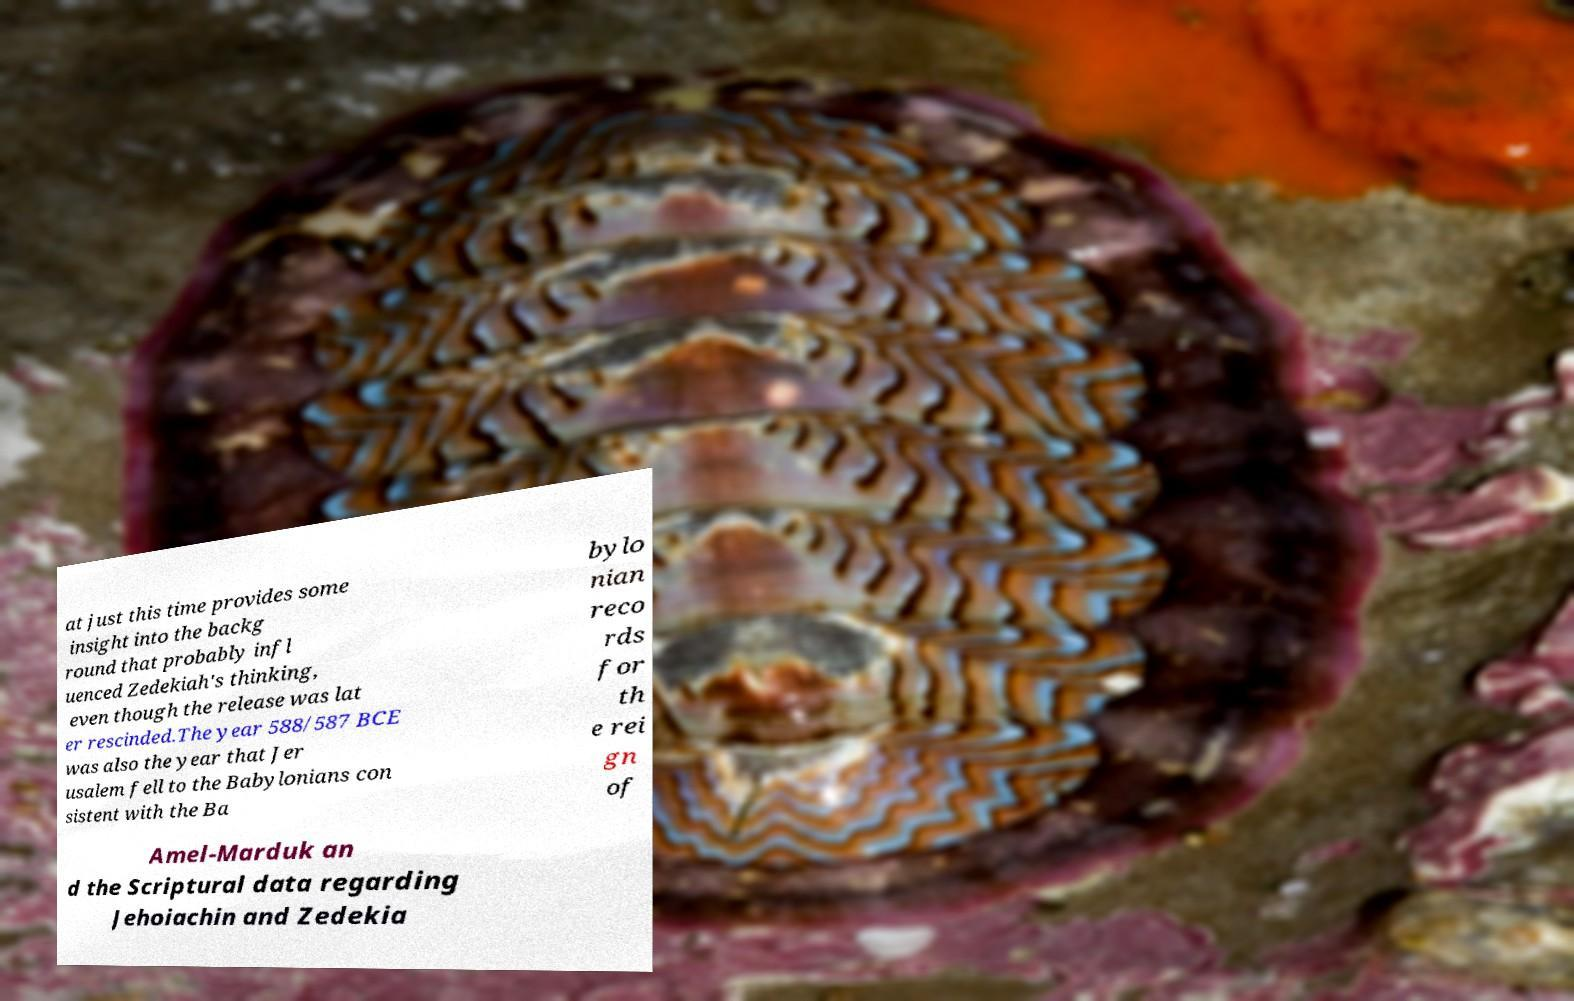Please identify and transcribe the text found in this image. at just this time provides some insight into the backg round that probably infl uenced Zedekiah's thinking, even though the release was lat er rescinded.The year 588/587 BCE was also the year that Jer usalem fell to the Babylonians con sistent with the Ba bylo nian reco rds for th e rei gn of Amel-Marduk an d the Scriptural data regarding Jehoiachin and Zedekia 